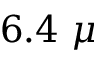Convert formula to latex. <formula><loc_0><loc_0><loc_500><loc_500>6 . 4 \mu</formula> 